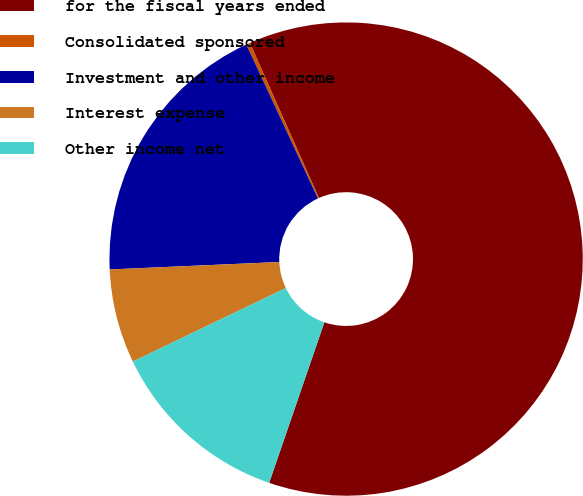Convert chart. <chart><loc_0><loc_0><loc_500><loc_500><pie_chart><fcel>for the fiscal years ended<fcel>Consolidated sponsored<fcel>Investment and other income<fcel>Interest expense<fcel>Other income net<nl><fcel>61.94%<fcel>0.26%<fcel>18.77%<fcel>6.43%<fcel>12.6%<nl></chart> 